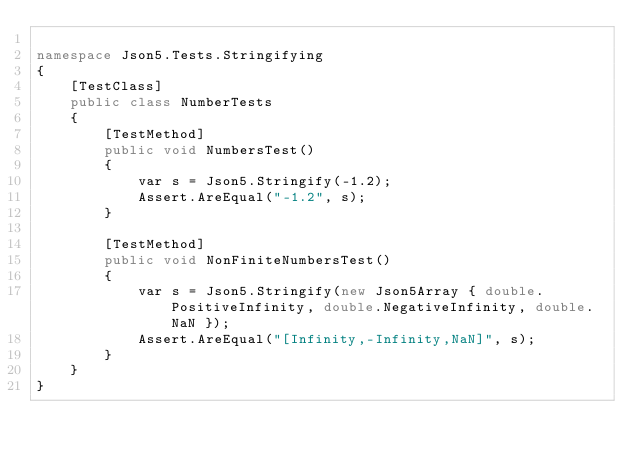Convert code to text. <code><loc_0><loc_0><loc_500><loc_500><_C#_>
namespace Json5.Tests.Stringifying
{
    [TestClass]
    public class NumberTests
    {
        [TestMethod]
        public void NumbersTest()
        {
            var s = Json5.Stringify(-1.2);
            Assert.AreEqual("-1.2", s);
        }

        [TestMethod]
        public void NonFiniteNumbersTest()
        {
            var s = Json5.Stringify(new Json5Array { double.PositiveInfinity, double.NegativeInfinity, double.NaN });
            Assert.AreEqual("[Infinity,-Infinity,NaN]", s);
        }
    }
}
</code> 